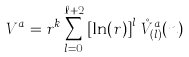<formula> <loc_0><loc_0><loc_500><loc_500>V ^ { a } = r ^ { k } \sum _ { l = 0 } ^ { \ell + 2 } \left [ \ln ( r ) \right ] ^ { l } \, \mathring { V } _ { ( l ) } ^ { a } ( n )</formula> 